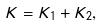Convert formula to latex. <formula><loc_0><loc_0><loc_500><loc_500>K = K _ { 1 } + K _ { 2 } ,</formula> 